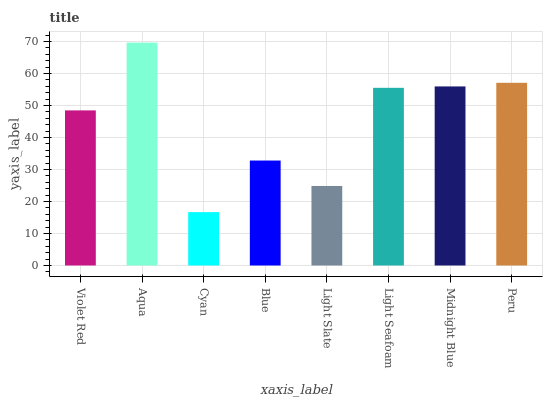Is Aqua the minimum?
Answer yes or no. No. Is Cyan the maximum?
Answer yes or no. No. Is Aqua greater than Cyan?
Answer yes or no. Yes. Is Cyan less than Aqua?
Answer yes or no. Yes. Is Cyan greater than Aqua?
Answer yes or no. No. Is Aqua less than Cyan?
Answer yes or no. No. Is Light Seafoam the high median?
Answer yes or no. Yes. Is Violet Red the low median?
Answer yes or no. Yes. Is Blue the high median?
Answer yes or no. No. Is Cyan the low median?
Answer yes or no. No. 